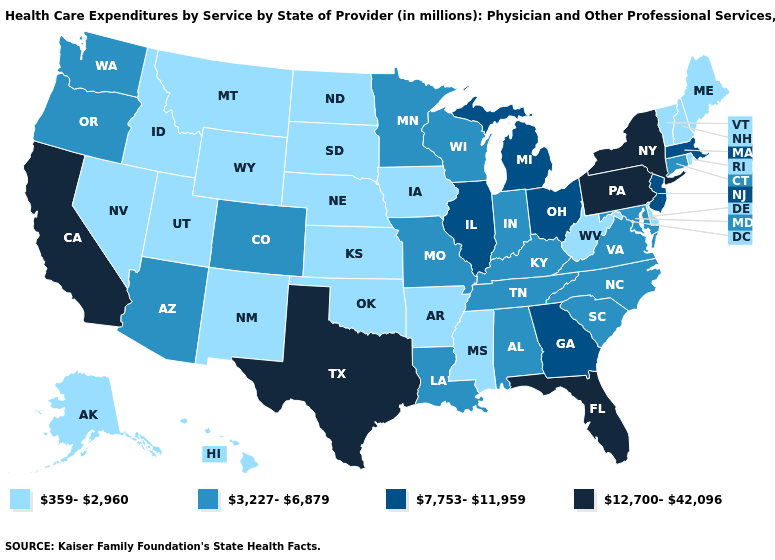Among the states that border California , which have the highest value?
Quick response, please. Arizona, Oregon. Name the states that have a value in the range 359-2,960?
Quick response, please. Alaska, Arkansas, Delaware, Hawaii, Idaho, Iowa, Kansas, Maine, Mississippi, Montana, Nebraska, Nevada, New Hampshire, New Mexico, North Dakota, Oklahoma, Rhode Island, South Dakota, Utah, Vermont, West Virginia, Wyoming. What is the highest value in the South ?
Be succinct. 12,700-42,096. Does New Hampshire have the highest value in the USA?
Concise answer only. No. What is the value of New Mexico?
Quick response, please. 359-2,960. Among the states that border Delaware , which have the highest value?
Concise answer only. Pennsylvania. What is the value of Wyoming?
Answer briefly. 359-2,960. What is the highest value in the Northeast ?
Write a very short answer. 12,700-42,096. What is the value of Indiana?
Write a very short answer. 3,227-6,879. Name the states that have a value in the range 3,227-6,879?
Keep it brief. Alabama, Arizona, Colorado, Connecticut, Indiana, Kentucky, Louisiana, Maryland, Minnesota, Missouri, North Carolina, Oregon, South Carolina, Tennessee, Virginia, Washington, Wisconsin. Does New Jersey have the lowest value in the USA?
Quick response, please. No. What is the lowest value in the USA?
Be succinct. 359-2,960. Among the states that border Alabama , which have the lowest value?
Short answer required. Mississippi. What is the highest value in the USA?
Write a very short answer. 12,700-42,096. Does the first symbol in the legend represent the smallest category?
Quick response, please. Yes. 